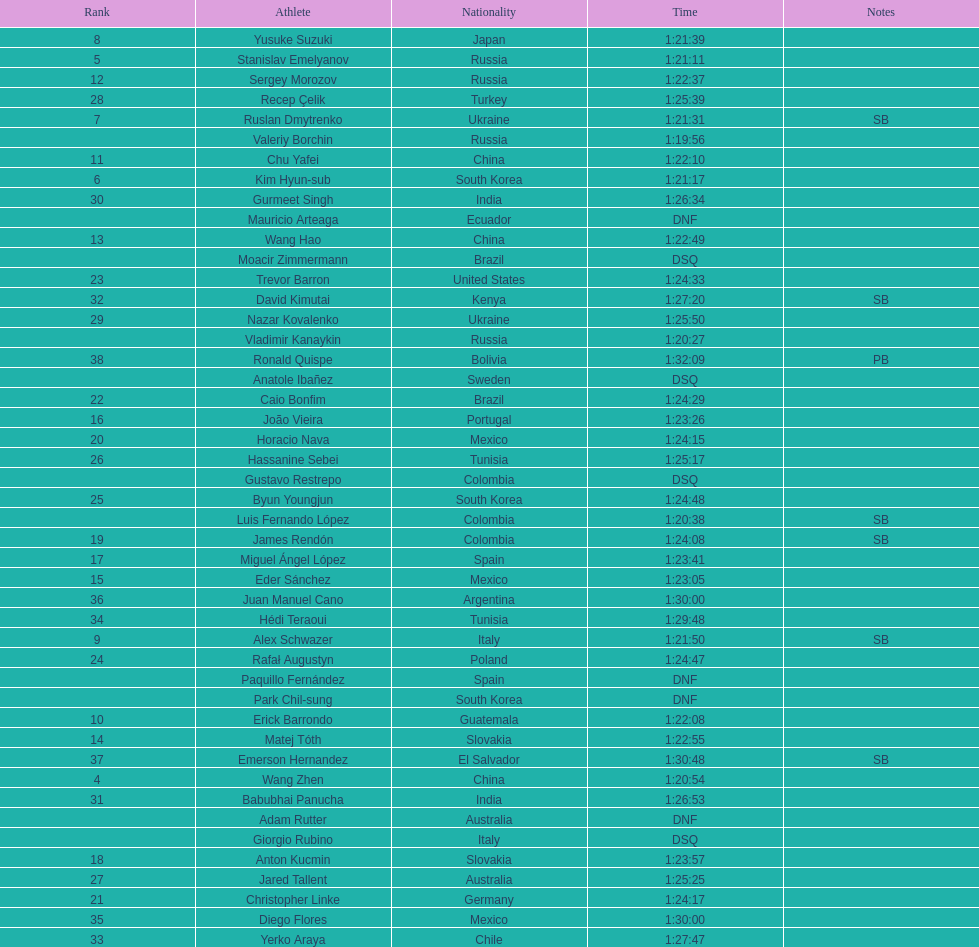How many russians finished at least 3rd in the 20km walk? 2. 